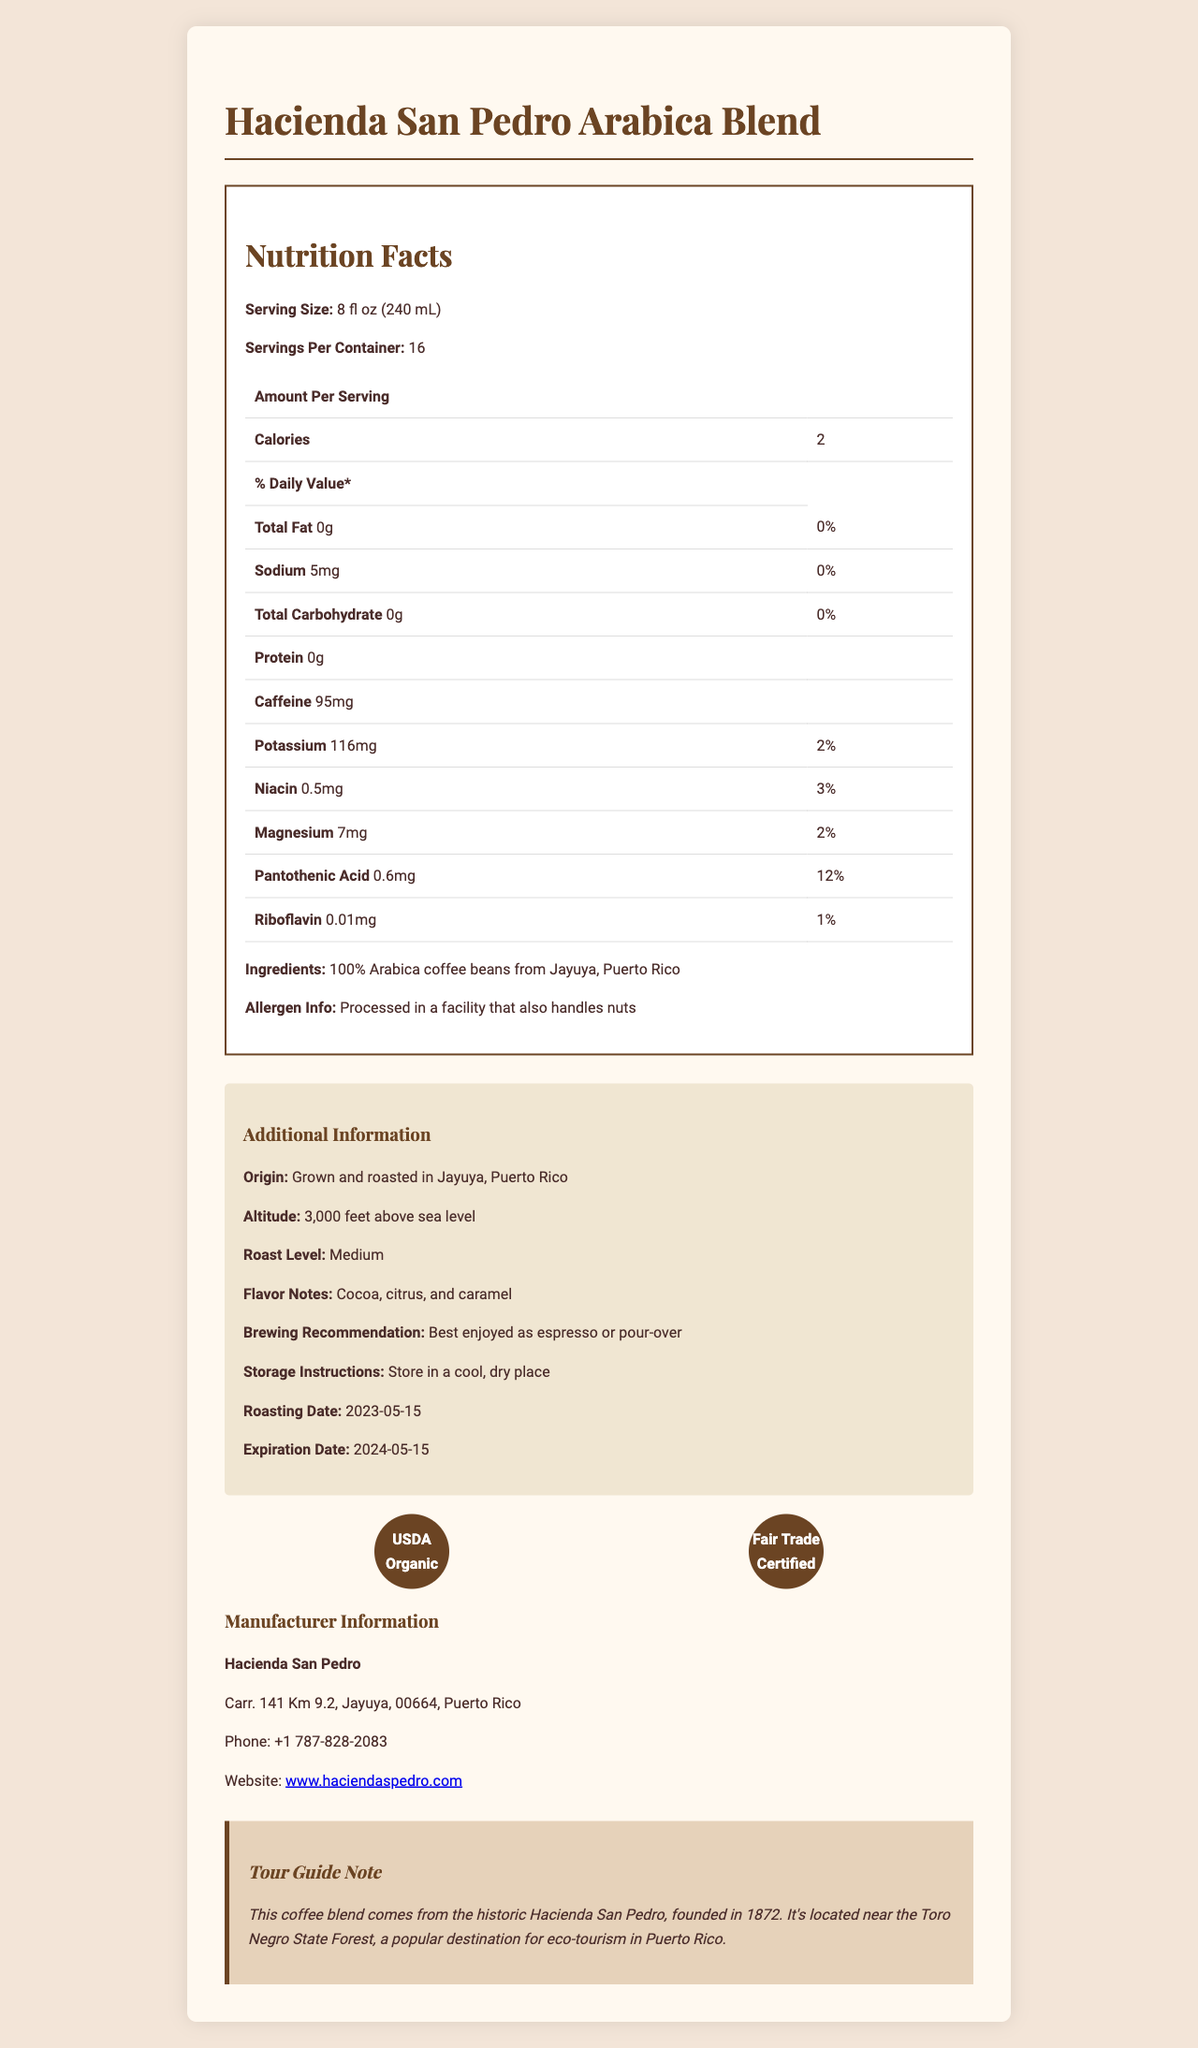What is the serving size of Hacienda San Pedro Arabica Blend? It is mentioned in the Nutrition Facts section under Serving Size.
Answer: 8 fl oz (240 mL) How many calories are in a serving of this coffee blend? It is listed as 2 calories per serving in the Nutrition Facts.
Answer: 2 How much potassium does one serving contain? The Nutrition Facts section lists potassium as 116mg per serving.
Answer: 116mg Who is the manufacturer of this coffee blend? The Manufacturer Information section states the name as Hacienda San Pedro.
Answer: Hacienda San Pedro What are the flavor notes of this coffee? The Additional Information section lists flavor notes as cocoa, citrus, and caramel.
Answer: Cocoa, citrus, and caramel What is the recommended brewing method for this coffee blend? A. Espresso B. French Press C. Pour-over D. Cold Brew The Additional Information section recommends enjoying it as espresso or pour-over.
Answer: A. Espresso and C. Pour-over Which certifications does this coffee blend have? A. USDA Organic B. Rainforest Alliance C. Fair Trade Certified D. Non-GMO Project Verified The Certifications section mentions USDA Organic and Fair Trade Certified.
Answer: A. USDA Organic and C. Fair Trade Certified Is this coffee blend suitable for someone with a nut allergy? The allergen information states it is processed in a facility that also handles nuts, which is risky for people with nut allergies.
Answer: No What is the main idea of this document? The document breaks down the coffee's nutritional content, origin, brewing advice, and other significant details in an organized manner to help the consumer understand the product comprehensively.
Answer: The document provides detailed information about the Hacienda San Pedro Arabica Blend coffee, including its nutrition facts, ingredients, certifications, additional information like flavor notes and brewing recommendations, manufacturer details, and a tour guide note about its origin. What is the altitude at which the coffee beans are grown? The Additional Information section states that the coffee is grown at an altitude of 3,000 feet above sea level.
Answer: 3,000 feet above sea level How much sodium is in one serving of the coffee? The Nutrition Facts section lists sodium content as 5mg per serving.
Answer: 5mg How long is the coffee blend’s shelf life? The roasting date is 2023-05-15, and the expiration date is 2024-05-15, indicating a shelf life of one year.
Answer: 1 year What is the daily value percentage of magnesium in one serving? The Nutrition Facts section shows that magnesium per serving has a daily value of 2%.
Answer: 2% Where is Hacienda San Pedro located? The Manufacturer Information section provides this address.
Answer: Carr. 141 Km 9.2, Jayuya, 00664, Puerto Rico Does the document mention if the coffee beans are blended with any other types of beans? The ingredients list states "100% Arabica coffee beans from Jayuya, Puerto Rico," implying no other types of beans are blended.
Answer: No What is the roasting level of the Hacienda San Pedro Arabica Blend? The Additional Information section specifies the roast level as Medium.
Answer: Medium When was the coffee roasted? The Roasting date is detailed in the Additional Information section.
Answer: 2023-05-15 Does the document provide information about the eco-tourism sites near Hacienda San Pedro? Although a tour guide note mentions the location is near the Toro Negro State Forest, it does not provide detailed information about the eco-tourism sites.
Answer: No 